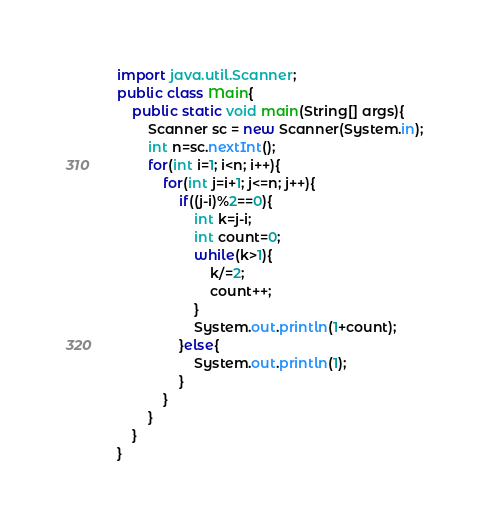<code> <loc_0><loc_0><loc_500><loc_500><_Java_>import java.util.Scanner;
public class Main{
	public static void main(String[] args){
		Scanner sc = new Scanner(System.in);
		int n=sc.nextInt();
		for(int i=1; i<n; i++){
			for(int j=i+1; j<=n; j++){
				if((j-i)%2==0){
					int k=j-i;
					int count=0;
					while(k>1){
						k/=2;
						count++;
					}
					System.out.println(1+count);
				}else{
					System.out.println(1);
				}
			}
		}
	}
}
</code> 